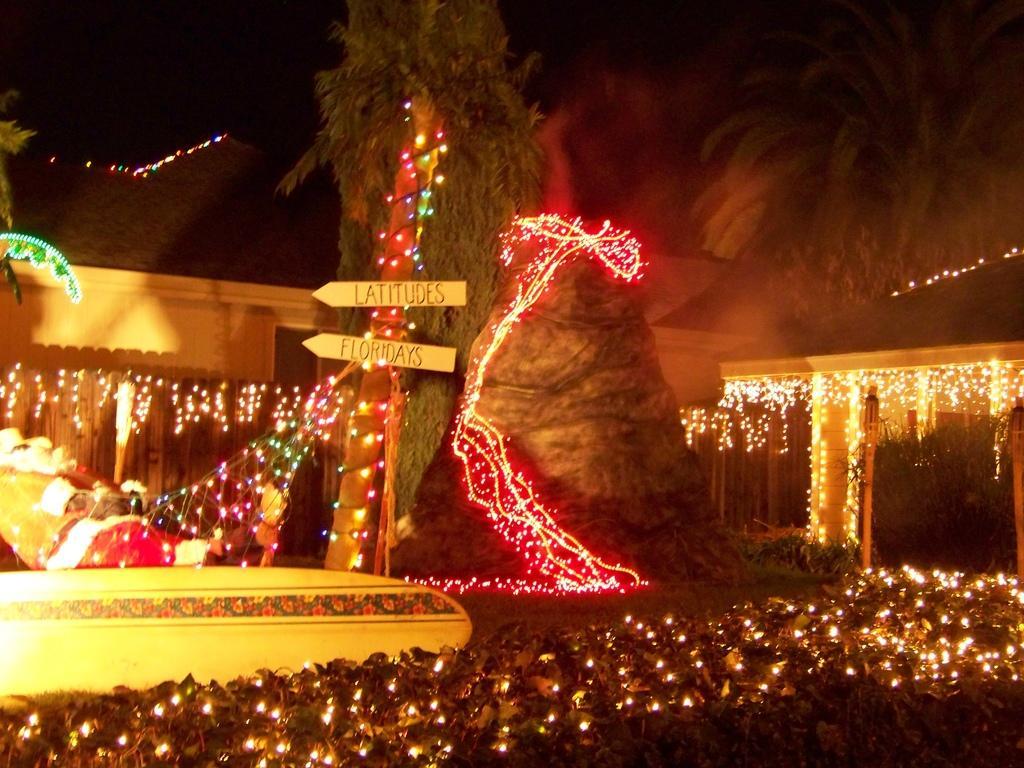Can you describe this image briefly? In the center of the image we can see trees and there are lights. At the bottom there are bushes. In the background there is a shed. At the top there is sky. 